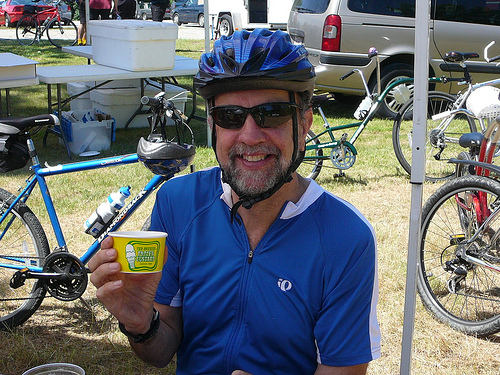How many people are in the photo? 1 